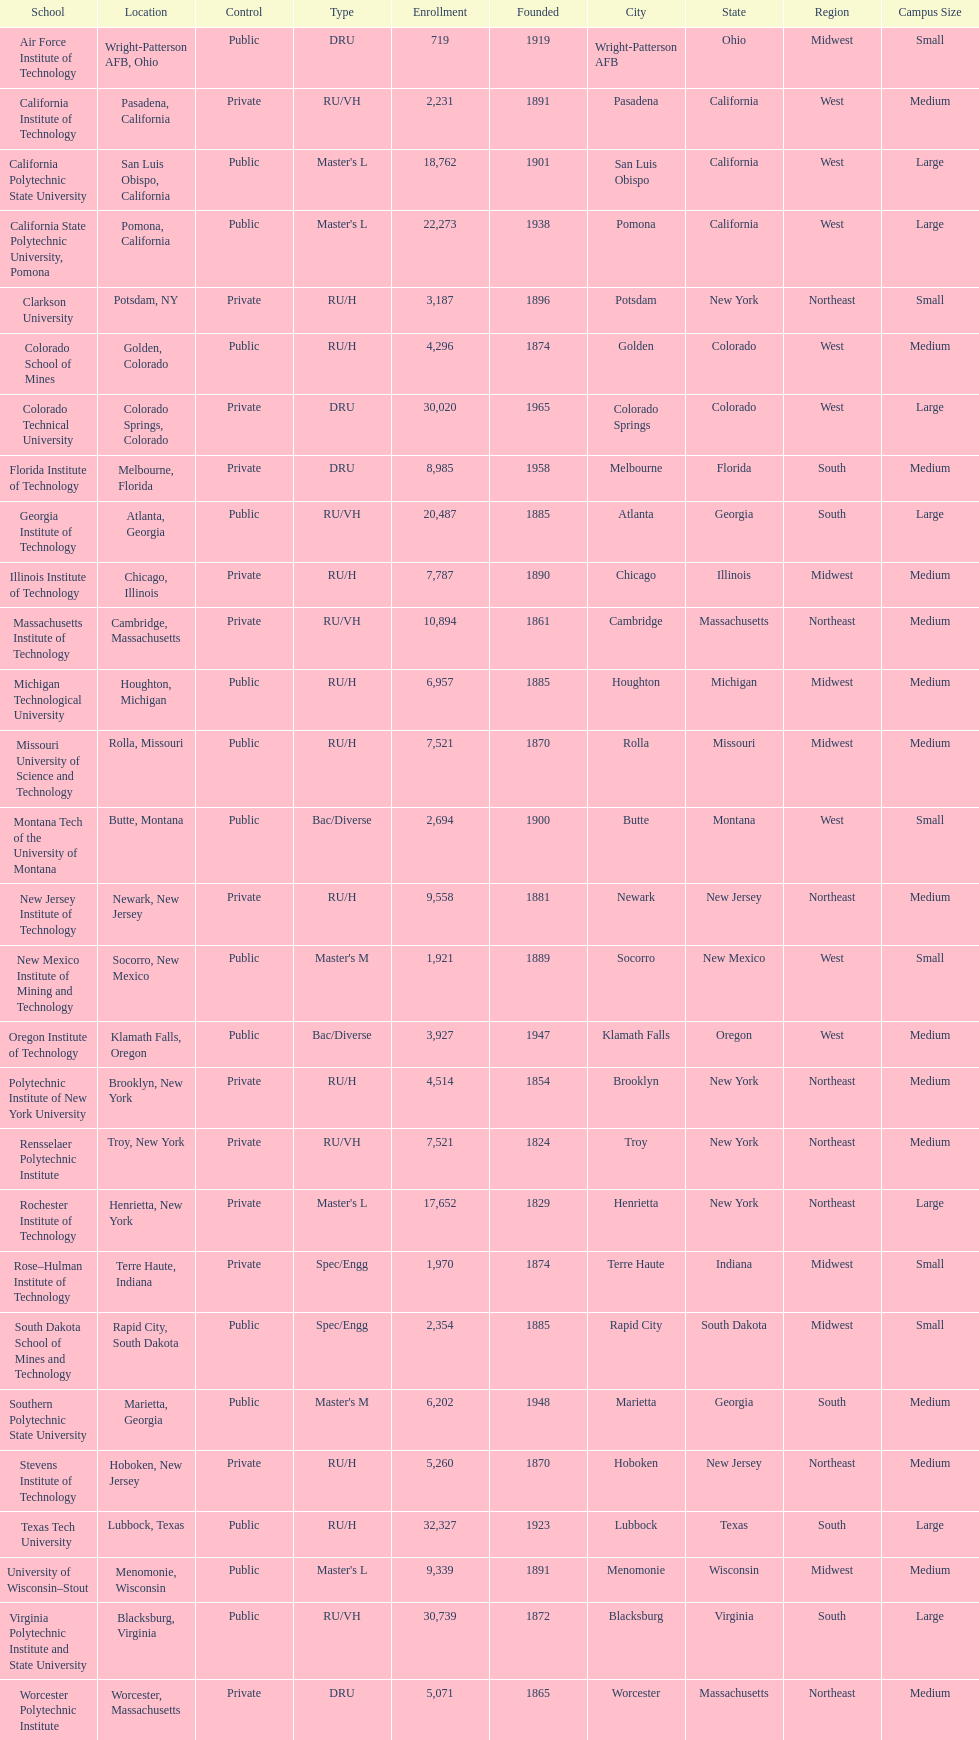What school is listed next after michigan technological university? Missouri University of Science and Technology. Help me parse the entirety of this table. {'header': ['School', 'Location', 'Control', 'Type', 'Enrollment', 'Founded', 'City', 'State', 'Region', 'Campus Size'], 'rows': [['Air Force Institute of Technology', 'Wright-Patterson AFB, Ohio', 'Public', 'DRU', '719', '1919', 'Wright-Patterson AFB', 'Ohio', 'Midwest', 'Small'], ['California Institute of Technology', 'Pasadena, California', 'Private', 'RU/VH', '2,231', '1891', 'Pasadena', 'California', 'West', 'Medium'], ['California Polytechnic State University', 'San Luis Obispo, California', 'Public', "Master's L", '18,762', '1901', 'San Luis Obispo', 'California', 'West', 'Large'], ['California State Polytechnic University, Pomona', 'Pomona, California', 'Public', "Master's L", '22,273', '1938', 'Pomona', 'California', 'West', 'Large'], ['Clarkson University', 'Potsdam, NY', 'Private', 'RU/H', '3,187', '1896', 'Potsdam', 'New York', 'Northeast', 'Small'], ['Colorado School of Mines', 'Golden, Colorado', 'Public', 'RU/H', '4,296', '1874', 'Golden', 'Colorado', 'West', 'Medium'], ['Colorado Technical University', 'Colorado Springs, Colorado', 'Private', 'DRU', '30,020', '1965', 'Colorado Springs', 'Colorado', 'West', 'Large'], ['Florida Institute of Technology', 'Melbourne, Florida', 'Private', 'DRU', '8,985', '1958', 'Melbourne', 'Florida', 'South', 'Medium'], ['Georgia Institute of Technology', 'Atlanta, Georgia', 'Public', 'RU/VH', '20,487', '1885', 'Atlanta', 'Georgia', 'South', 'Large'], ['Illinois Institute of Technology', 'Chicago, Illinois', 'Private', 'RU/H', '7,787', '1890', 'Chicago', 'Illinois', 'Midwest', 'Medium'], ['Massachusetts Institute of Technology', 'Cambridge, Massachusetts', 'Private', 'RU/VH', '10,894', '1861', 'Cambridge', 'Massachusetts', 'Northeast', 'Medium'], ['Michigan Technological University', 'Houghton, Michigan', 'Public', 'RU/H', '6,957', '1885', 'Houghton', 'Michigan', 'Midwest', 'Medium'], ['Missouri University of Science and Technology', 'Rolla, Missouri', 'Public', 'RU/H', '7,521', '1870', 'Rolla', 'Missouri', 'Midwest', 'Medium'], ['Montana Tech of the University of Montana', 'Butte, Montana', 'Public', 'Bac/Diverse', '2,694', '1900', 'Butte', 'Montana', 'West', 'Small'], ['New Jersey Institute of Technology', 'Newark, New Jersey', 'Private', 'RU/H', '9,558', '1881', 'Newark', 'New Jersey', 'Northeast', 'Medium'], ['New Mexico Institute of Mining and Technology', 'Socorro, New Mexico', 'Public', "Master's M", '1,921', '1889', 'Socorro', 'New Mexico', 'West', 'Small'], ['Oregon Institute of Technology', 'Klamath Falls, Oregon', 'Public', 'Bac/Diverse', '3,927', '1947', 'Klamath Falls', 'Oregon', 'West', 'Medium'], ['Polytechnic Institute of New York University', 'Brooklyn, New York', 'Private', 'RU/H', '4,514', '1854', 'Brooklyn', 'New York', 'Northeast', 'Medium'], ['Rensselaer Polytechnic Institute', 'Troy, New York', 'Private', 'RU/VH', '7,521', '1824', 'Troy', 'New York', 'Northeast', 'Medium'], ['Rochester Institute of Technology', 'Henrietta, New York', 'Private', "Master's L", '17,652', '1829', 'Henrietta', 'New York', 'Northeast', 'Large'], ['Rose–Hulman Institute of Technology', 'Terre Haute, Indiana', 'Private', 'Spec/Engg', '1,970', '1874', 'Terre Haute', 'Indiana', 'Midwest', 'Small'], ['South Dakota School of Mines and Technology', 'Rapid City, South Dakota', 'Public', 'Spec/Engg', '2,354', '1885', 'Rapid City', 'South Dakota', 'Midwest', 'Small'], ['Southern Polytechnic State University', 'Marietta, Georgia', 'Public', "Master's M", '6,202', '1948', 'Marietta', 'Georgia', 'South', 'Medium'], ['Stevens Institute of Technology', 'Hoboken, New Jersey', 'Private', 'RU/H', '5,260', '1870', 'Hoboken', 'New Jersey', 'Northeast', 'Medium'], ['Texas Tech University', 'Lubbock, Texas', 'Public', 'RU/H', '32,327', '1923', 'Lubbock', 'Texas', 'South', 'Large'], ['University of Wisconsin–Stout', 'Menomonie, Wisconsin', 'Public', "Master's L", '9,339', '1891', 'Menomonie', 'Wisconsin', 'Midwest', 'Medium'], ['Virginia Polytechnic Institute and State University', 'Blacksburg, Virginia', 'Public', 'RU/VH', '30,739', '1872', 'Blacksburg', 'Virginia', 'South', 'Large'], ['Worcester Polytechnic Institute', 'Worcester, Massachusetts', 'Private', 'DRU', '5,071', '1865', 'Worcester', 'Massachusetts', 'Northeast', 'Medium']]} 